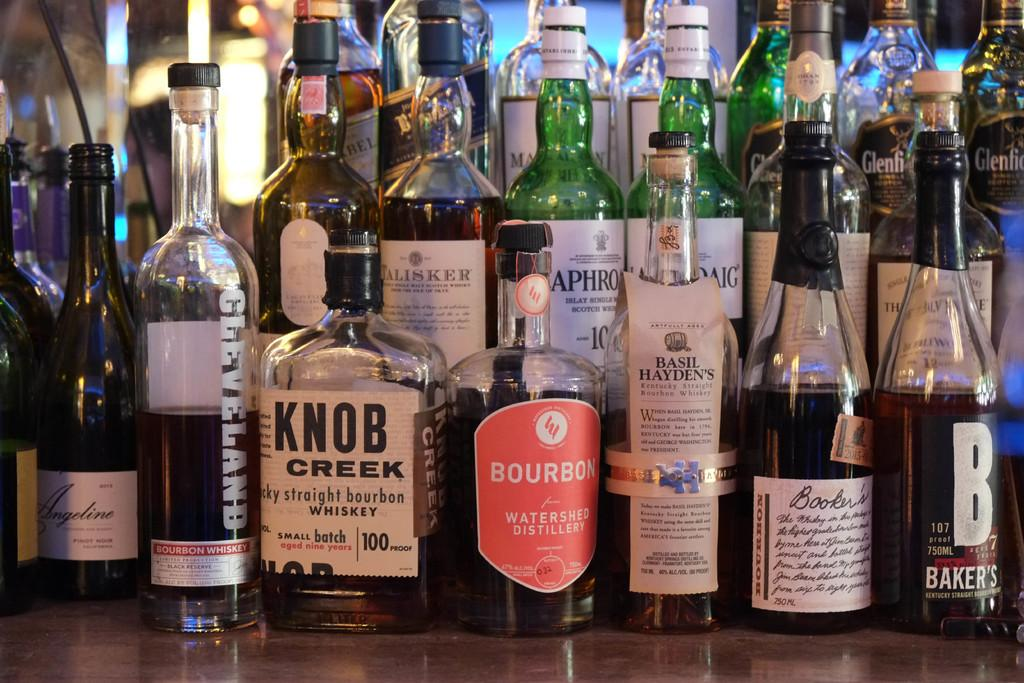Provide a one-sentence caption for the provided image. A bottle of Knob Creek whiskey sits with many other bottles at a bar. 